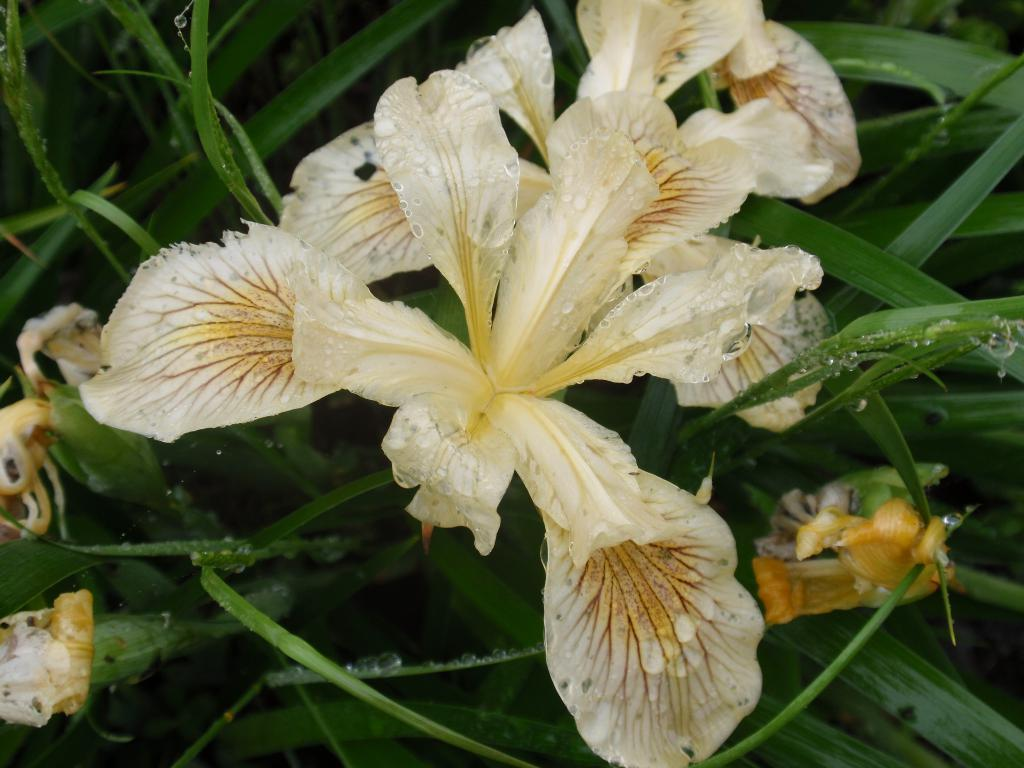What types of plants are visible in the foreground of the image? There are flowers in the foreground of the image. What types of plants can be seen in the background of the image? There are plants in the background of the image. Can you see the sun setting on the dock in the image? There is no dock or sunset present in the image; it features flowers and plants. 